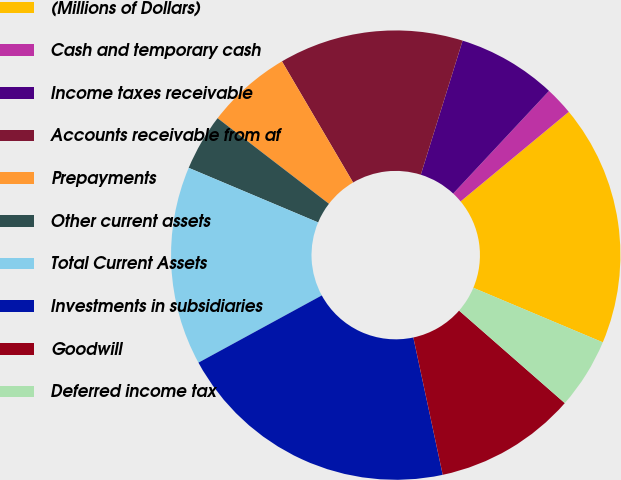Convert chart to OTSL. <chart><loc_0><loc_0><loc_500><loc_500><pie_chart><fcel>(Millions of Dollars)<fcel>Cash and temporary cash<fcel>Income taxes receivable<fcel>Accounts receivable from af<fcel>Prepayments<fcel>Other current assets<fcel>Total Current Assets<fcel>Investments in subsidiaries<fcel>Goodwill<fcel>Deferred income tax<nl><fcel>17.35%<fcel>2.04%<fcel>7.14%<fcel>13.26%<fcel>6.12%<fcel>4.08%<fcel>14.29%<fcel>20.41%<fcel>10.2%<fcel>5.1%<nl></chart> 